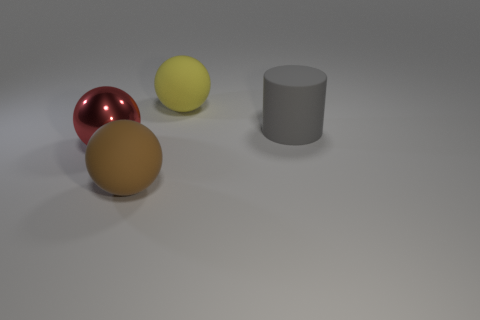Is there anything else that is made of the same material as the large red thing?
Your answer should be very brief. No. Is there anything else that has the same shape as the gray thing?
Your response must be concise. No. Are there any green matte cylinders that have the same size as the gray rubber cylinder?
Provide a short and direct response. No. What color is the large rubber cylinder?
Provide a short and direct response. Gray. Does the cylinder have the same size as the yellow matte object?
Provide a succinct answer. Yes. What number of objects are big gray shiny cubes or large matte objects?
Make the answer very short. 3. Is the number of large gray things right of the brown ball the same as the number of tiny red matte balls?
Offer a very short reply. No. There is a rubber ball that is in front of the thing that is behind the big gray cylinder; are there any large brown rubber things to the left of it?
Offer a very short reply. No. There is another sphere that is made of the same material as the big brown sphere; what color is it?
Provide a short and direct response. Yellow. There is a rubber sphere that is in front of the yellow matte object; does it have the same color as the shiny thing?
Your answer should be compact. No. 